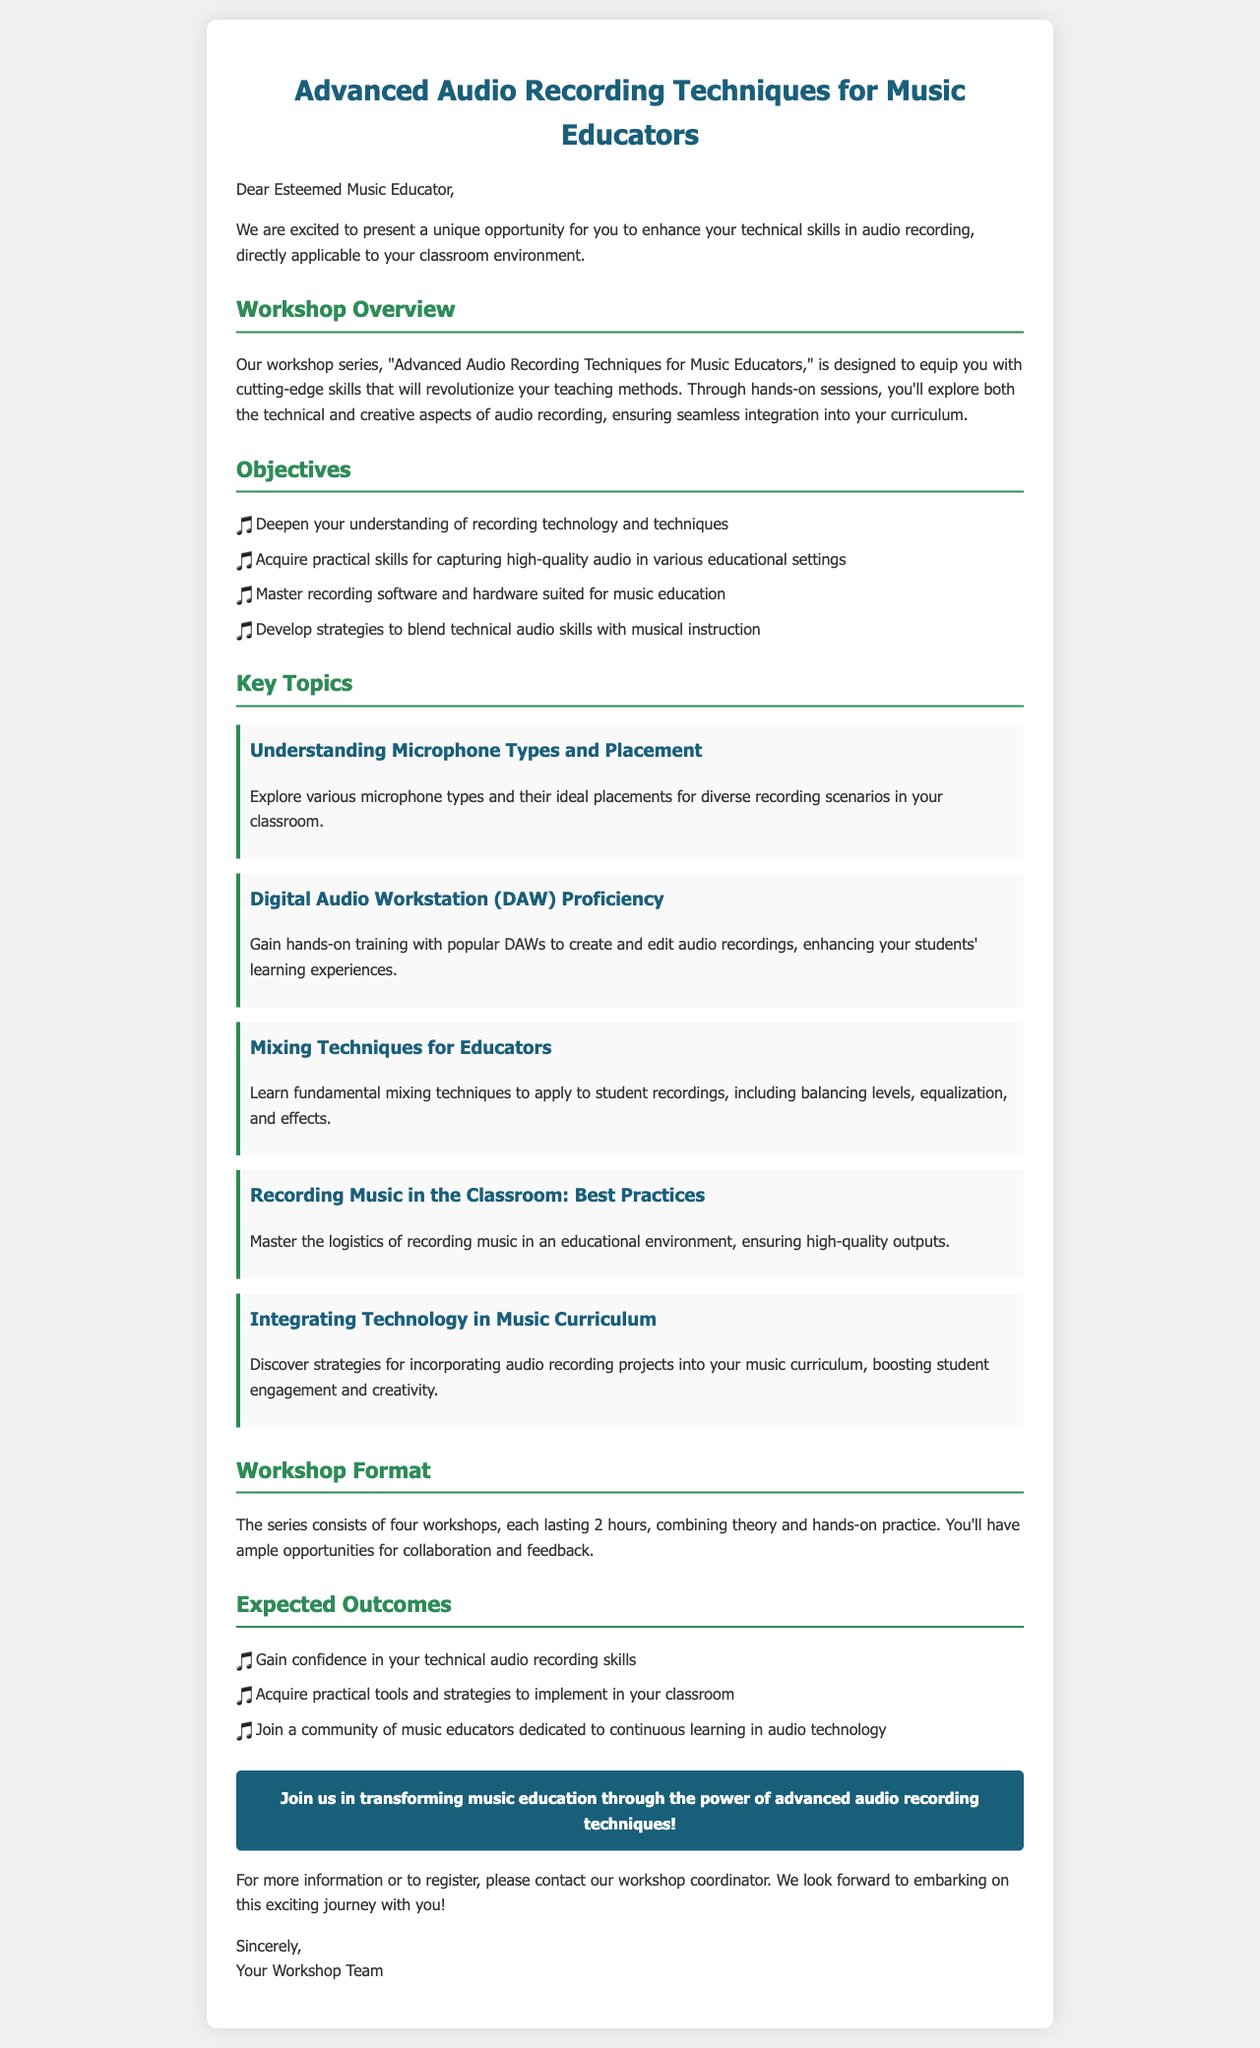What is the title of the workshop series? The title is explicitly stated in the document as "Advanced Audio Recording Techniques for Music Educators."
Answer: Advanced Audio Recording Techniques for Music Educators How long is each workshop? The document states that each workshop lasts 2 hours, which provides a clear duration for attendees.
Answer: 2 hours What are the four key topics covered in the workshop? The document outlines several key topics; however, it specifically lists five distinct topics to provide a comprehensive overview.
Answer: Understanding Microphone Types and Placement, Digital Audio Workstation (DAW) Proficiency, Mixing Techniques for Educators, Recording Music in the Classroom: Best Practices, Integrating Technology in Music Curriculum What is one objective of the workshop series? The document lists objectives, and one example that captures a critical aspect is acquiring practical skills for audio recording.
Answer: Acquire practical skills for capturing high-quality audio in various educational settings What is the expected outcome related to community building? The document emphasizes joining a community of educators as a key outcome that indicates collaboration and support among peers.
Answer: Join a community of music educators dedicated to continuous learning in audio technology 